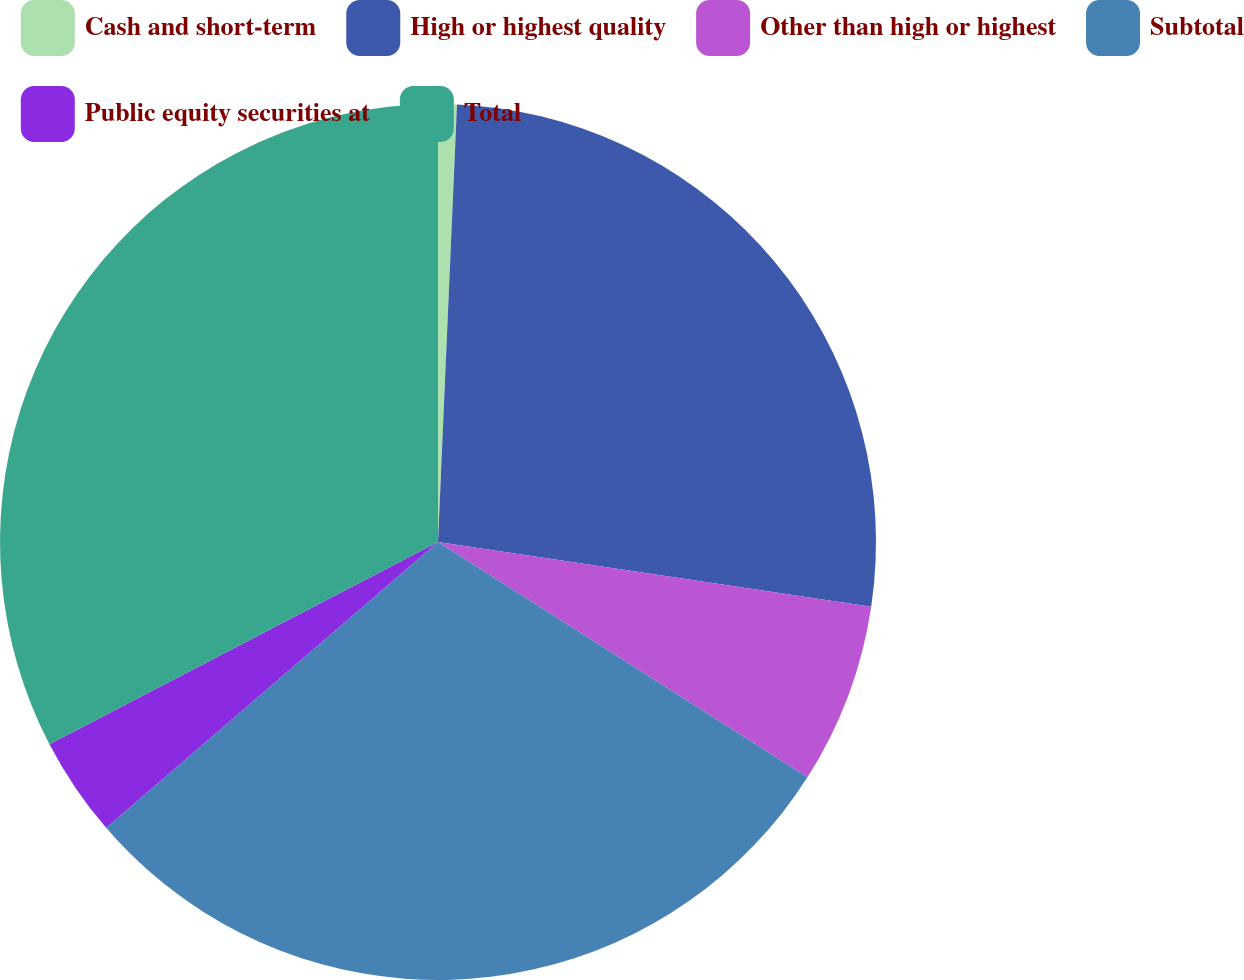<chart> <loc_0><loc_0><loc_500><loc_500><pie_chart><fcel>Cash and short-term<fcel>High or highest quality<fcel>Other than high or highest<fcel>Subtotal<fcel>Public equity securities at<fcel>Total<nl><fcel>0.69%<fcel>26.67%<fcel>6.67%<fcel>29.66%<fcel>3.68%<fcel>32.64%<nl></chart> 